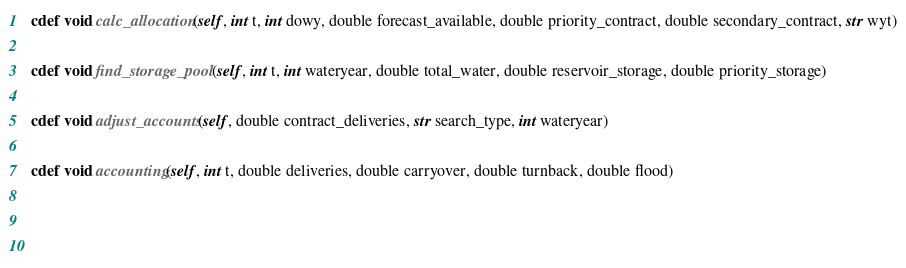<code> <loc_0><loc_0><loc_500><loc_500><_Cython_>  cdef void calc_allocation(self, int t, int dowy, double forecast_available, double priority_contract, double secondary_contract, str wyt)

  cdef void find_storage_pool(self, int t, int wateryear, double total_water, double reservoir_storage, double priority_storage)

  cdef void adjust_accounts(self, double contract_deliveries, str search_type, int wateryear)

  cdef void accounting(self, int t, double deliveries, double carryover, double turnback, double flood)


  </code> 